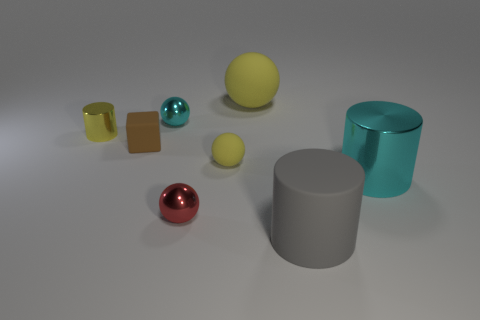Is there a tiny sphere of the same color as the small shiny cylinder?
Provide a short and direct response. Yes. Is there any other thing that has the same shape as the brown object?
Your answer should be compact. No. The small cylinder that is the same material as the red ball is what color?
Keep it short and to the point. Yellow. What number of objects are small cyan metal balls or cyan cylinders?
Offer a terse response. 2. There is a brown block; does it have the same size as the cylinder that is to the right of the gray rubber cylinder?
Offer a very short reply. No. There is a tiny shiny sphere in front of the small yellow ball left of the cyan object on the right side of the gray cylinder; what color is it?
Give a very brief answer. Red. The small metallic cylinder is what color?
Give a very brief answer. Yellow. Are there more large gray objects that are in front of the big gray object than small cyan metal balls that are behind the big matte sphere?
Offer a very short reply. No. There is a large yellow thing; is its shape the same as the tiny yellow object in front of the tiny brown matte block?
Your answer should be compact. Yes. Does the metallic thing on the right side of the large gray cylinder have the same size as the yellow rubber ball to the right of the small yellow rubber ball?
Make the answer very short. Yes. 